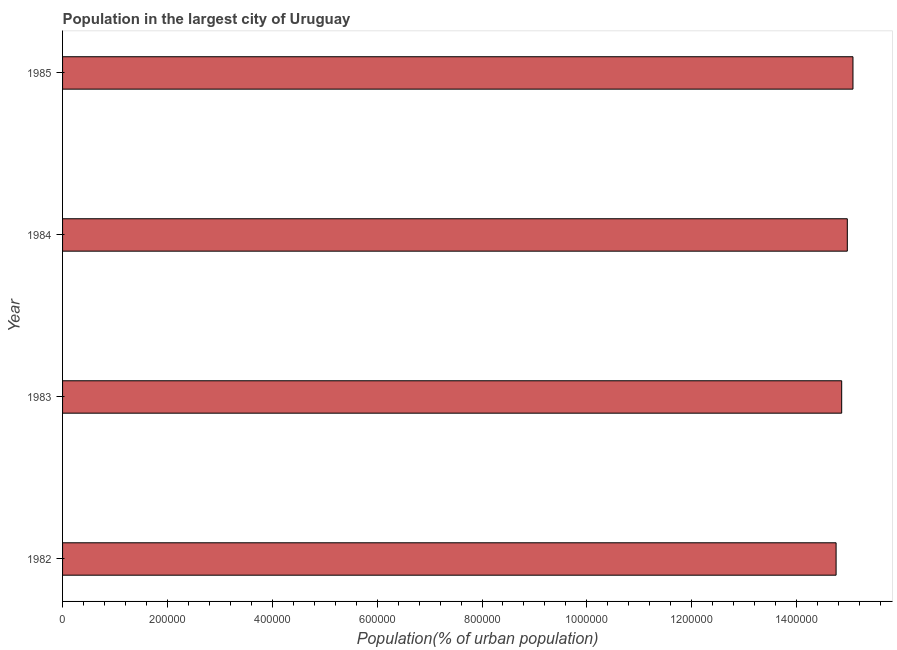Does the graph contain any zero values?
Provide a succinct answer. No. Does the graph contain grids?
Make the answer very short. No. What is the title of the graph?
Your response must be concise. Population in the largest city of Uruguay. What is the label or title of the X-axis?
Keep it short and to the point. Population(% of urban population). What is the label or title of the Y-axis?
Ensure brevity in your answer.  Year. What is the population in largest city in 1984?
Offer a very short reply. 1.50e+06. Across all years, what is the maximum population in largest city?
Give a very brief answer. 1.51e+06. Across all years, what is the minimum population in largest city?
Your response must be concise. 1.48e+06. What is the sum of the population in largest city?
Provide a short and direct response. 5.97e+06. What is the difference between the population in largest city in 1982 and 1984?
Your answer should be very brief. -2.14e+04. What is the average population in largest city per year?
Your response must be concise. 1.49e+06. What is the median population in largest city?
Your answer should be very brief. 1.49e+06. Do a majority of the years between 1984 and 1982 (inclusive) have population in largest city greater than 1120000 %?
Ensure brevity in your answer.  Yes. Is the population in largest city in 1982 less than that in 1984?
Your answer should be very brief. Yes. What is the difference between the highest and the second highest population in largest city?
Your answer should be compact. 1.08e+04. What is the difference between the highest and the lowest population in largest city?
Provide a succinct answer. 3.22e+04. How many years are there in the graph?
Your answer should be compact. 4. What is the Population(% of urban population) in 1982?
Ensure brevity in your answer.  1.48e+06. What is the Population(% of urban population) in 1983?
Offer a very short reply. 1.49e+06. What is the Population(% of urban population) in 1984?
Your answer should be very brief. 1.50e+06. What is the Population(% of urban population) in 1985?
Make the answer very short. 1.51e+06. What is the difference between the Population(% of urban population) in 1982 and 1983?
Offer a terse response. -1.06e+04. What is the difference between the Population(% of urban population) in 1982 and 1984?
Offer a very short reply. -2.14e+04. What is the difference between the Population(% of urban population) in 1982 and 1985?
Make the answer very short. -3.22e+04. What is the difference between the Population(% of urban population) in 1983 and 1984?
Provide a succinct answer. -1.07e+04. What is the difference between the Population(% of urban population) in 1983 and 1985?
Offer a very short reply. -2.15e+04. What is the difference between the Population(% of urban population) in 1984 and 1985?
Offer a terse response. -1.08e+04. What is the ratio of the Population(% of urban population) in 1982 to that in 1983?
Your answer should be compact. 0.99. What is the ratio of the Population(% of urban population) in 1982 to that in 1984?
Provide a succinct answer. 0.99. What is the ratio of the Population(% of urban population) in 1983 to that in 1985?
Provide a succinct answer. 0.99. What is the ratio of the Population(% of urban population) in 1984 to that in 1985?
Keep it short and to the point. 0.99. 